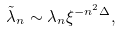<formula> <loc_0><loc_0><loc_500><loc_500>\tilde { \lambda } _ { n } \sim \lambda _ { n } \xi ^ { - n ^ { 2 } \Delta } ,</formula> 